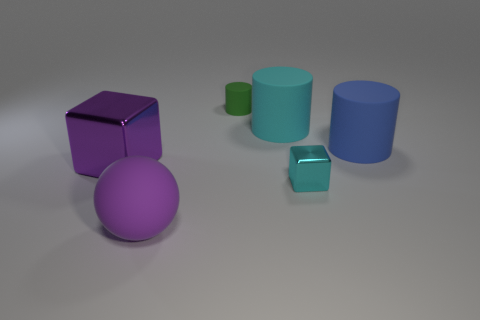Subtract all large matte cylinders. How many cylinders are left? 1 Subtract all purple cubes. How many cubes are left? 1 Subtract 1 balls. How many balls are left? 0 Add 3 big blue rubber cylinders. How many objects exist? 9 Subtract all tiny yellow things. Subtract all rubber cylinders. How many objects are left? 3 Add 4 metal objects. How many metal objects are left? 6 Add 5 purple rubber spheres. How many purple rubber spheres exist? 6 Subtract 0 red blocks. How many objects are left? 6 Subtract all spheres. How many objects are left? 5 Subtract all red balls. Subtract all purple cubes. How many balls are left? 1 